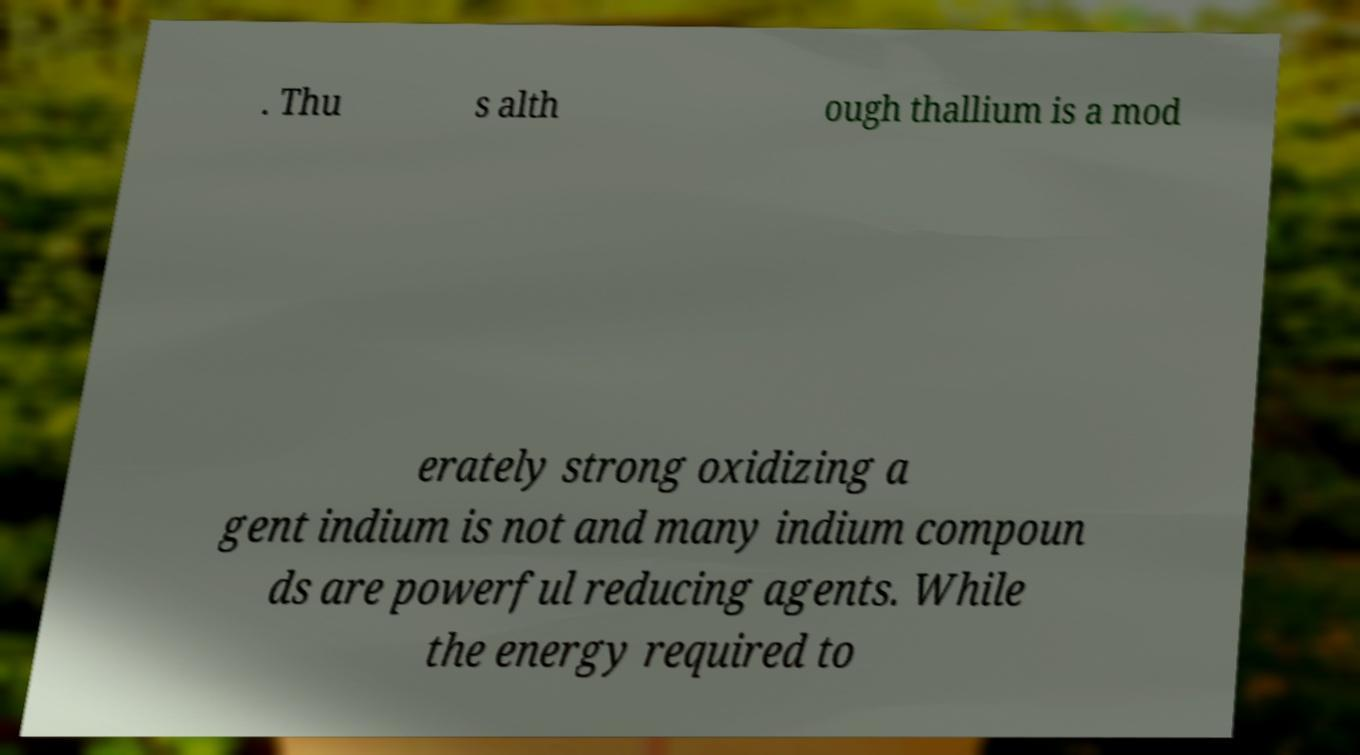Can you accurately transcribe the text from the provided image for me? . Thu s alth ough thallium is a mod erately strong oxidizing a gent indium is not and many indium compoun ds are powerful reducing agents. While the energy required to 